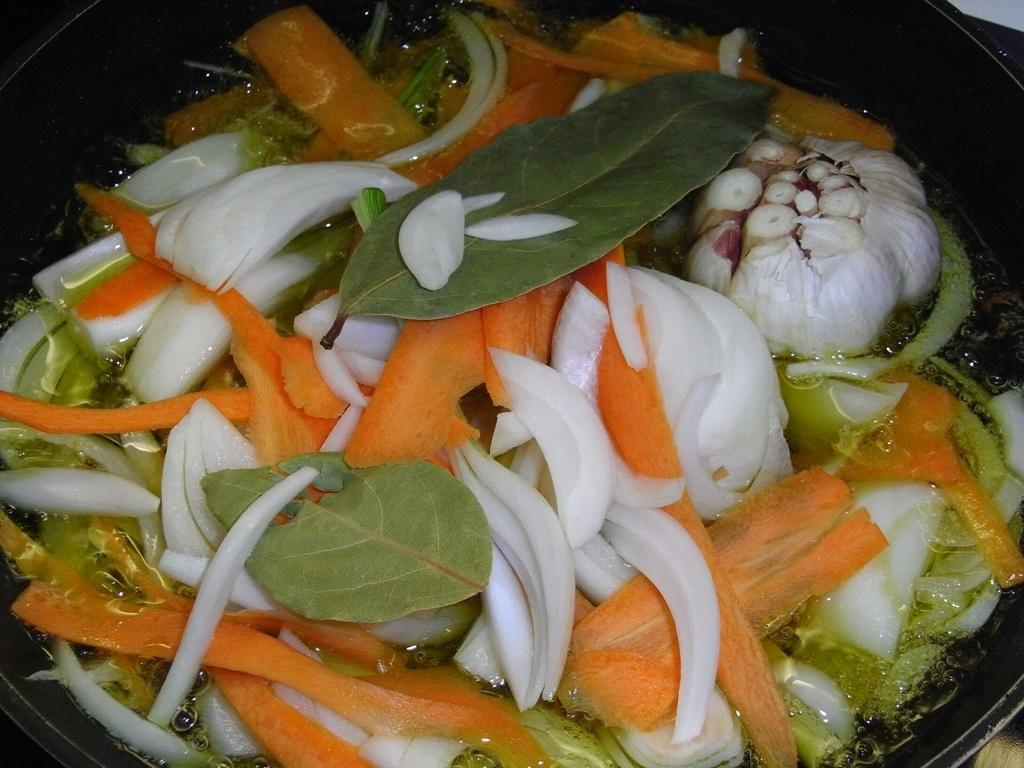What is present on the plate in the image? There are food items in a plate in the image. What type of plants can be seen growing in the daughter's hair in the image? There is no daughter or plants present in the image; it only features a plate with food items. 